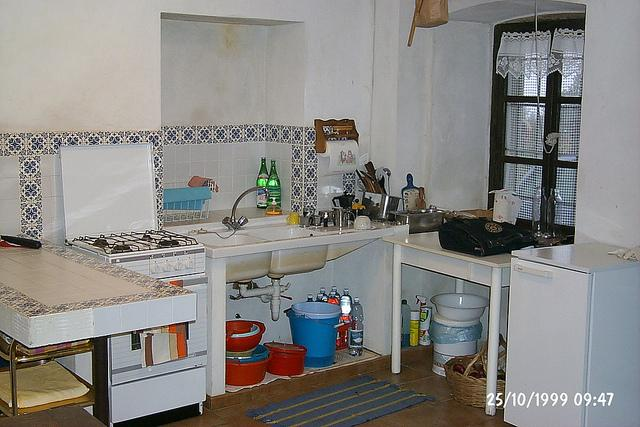What is the large circular blue object under the sink? bucket 